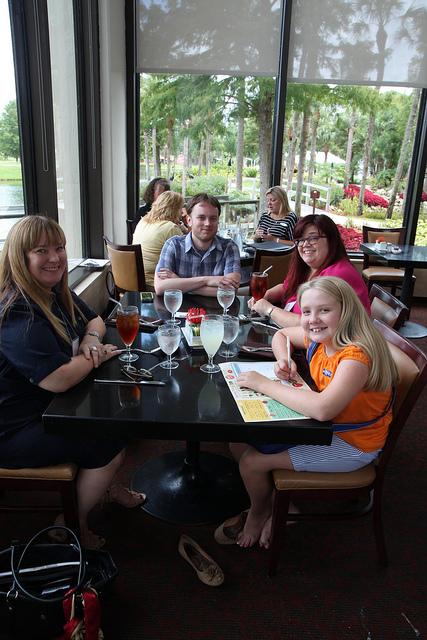How many people in the photo?
Keep it brief. 7. Is this a house or a restaurant?
Give a very brief answer. Restaurant. Is this photo taken in the nighttime?
Give a very brief answer. No. 